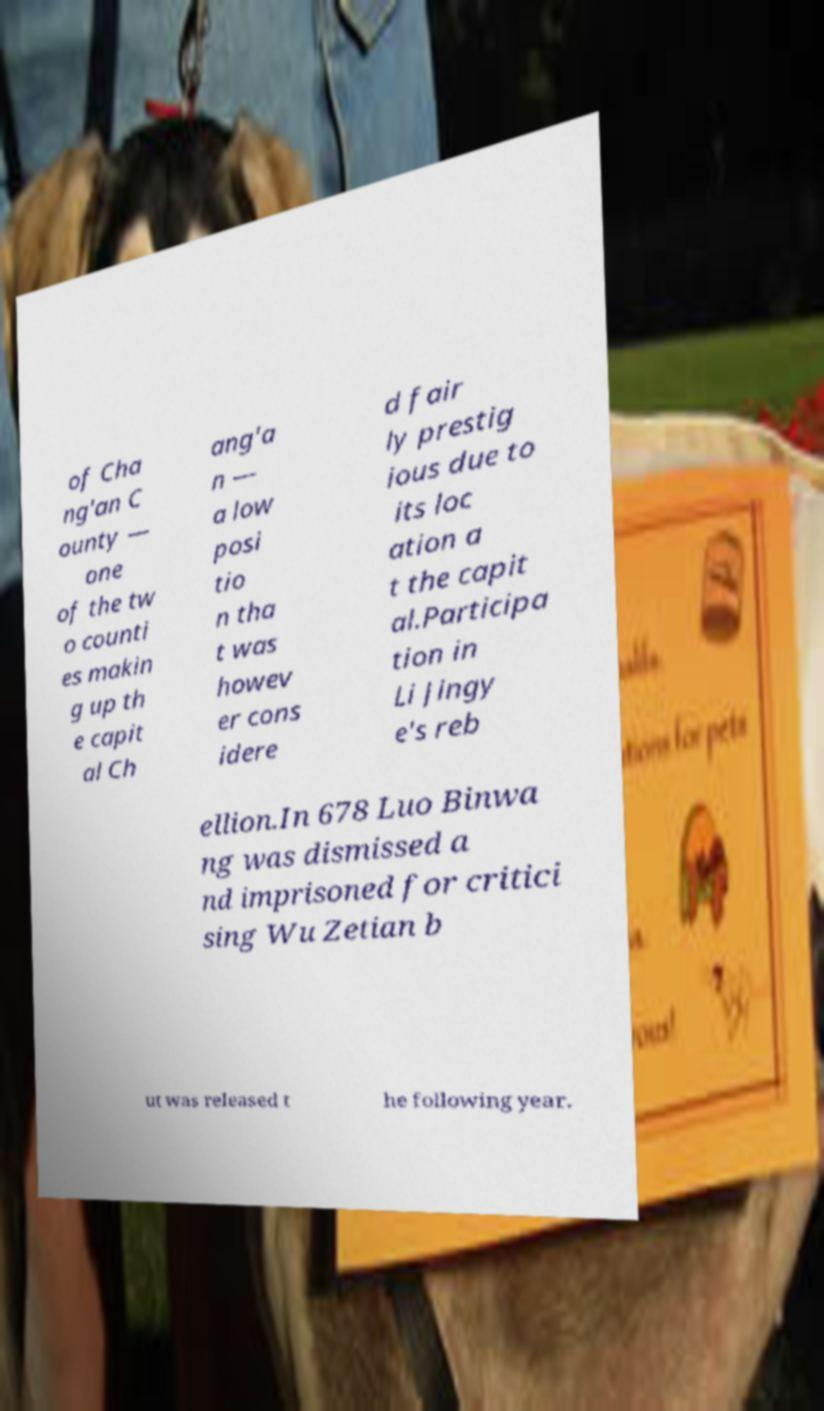I need the written content from this picture converted into text. Can you do that? of Cha ng'an C ounty — one of the tw o counti es makin g up th e capit al Ch ang'a n — a low posi tio n tha t was howev er cons idere d fair ly prestig ious due to its loc ation a t the capit al.Participa tion in Li Jingy e's reb ellion.In 678 Luo Binwa ng was dismissed a nd imprisoned for critici sing Wu Zetian b ut was released t he following year. 